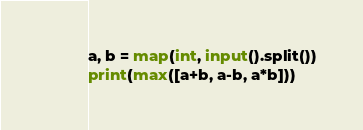<code> <loc_0><loc_0><loc_500><loc_500><_Python_>a, b = map(int, input().split())
print(max([a+b, a-b, a*b]))</code> 